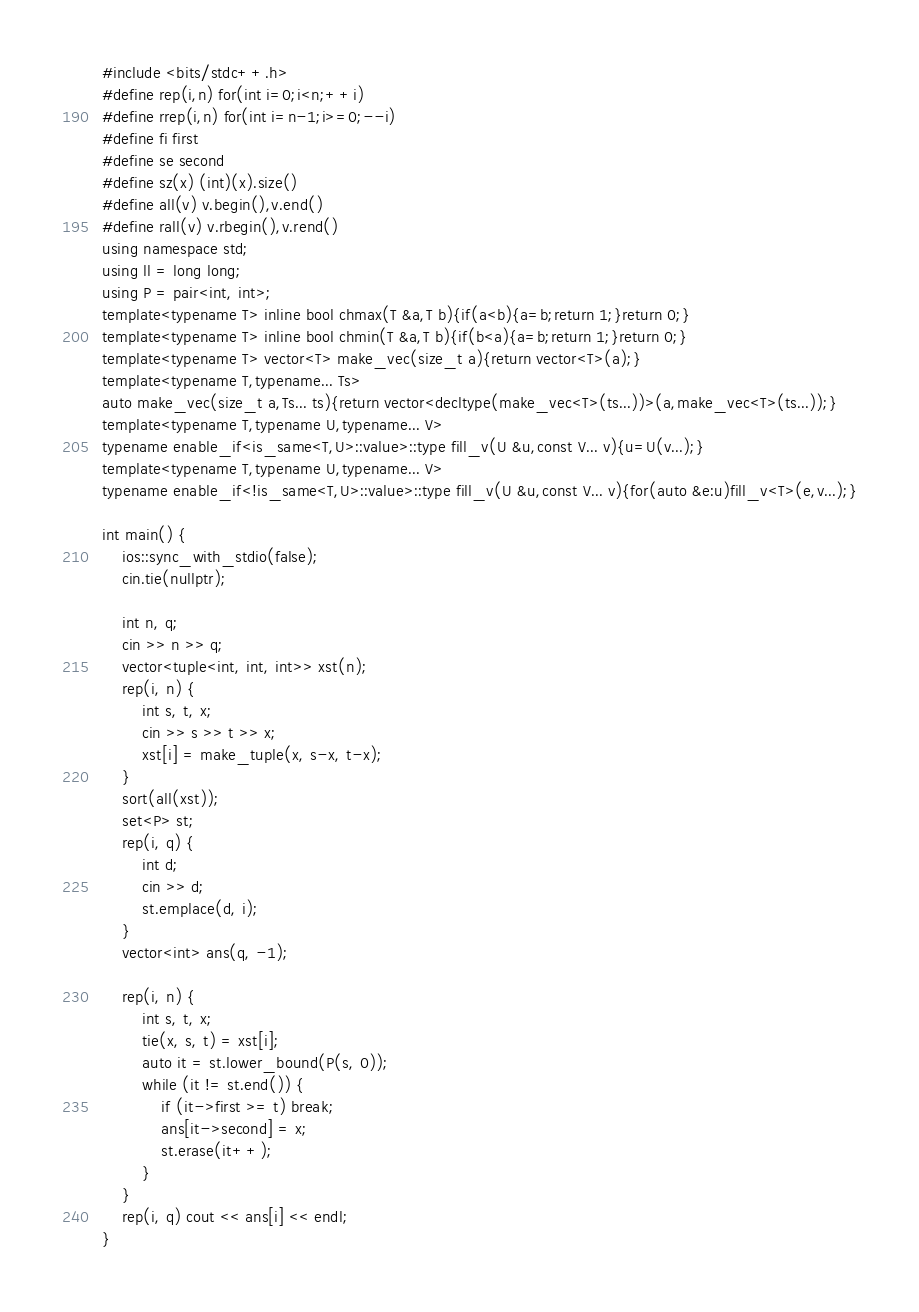Convert code to text. <code><loc_0><loc_0><loc_500><loc_500><_C++_>#include <bits/stdc++.h>
#define rep(i,n) for(int i=0;i<n;++i)
#define rrep(i,n) for(int i=n-1;i>=0;--i)
#define fi first
#define se second
#define sz(x) (int)(x).size()
#define all(v) v.begin(),v.end()
#define rall(v) v.rbegin(),v.rend()
using namespace std;
using ll = long long;
using P = pair<int, int>;
template<typename T> inline bool chmax(T &a,T b){if(a<b){a=b;return 1;}return 0;}
template<typename T> inline bool chmin(T &a,T b){if(b<a){a=b;return 1;}return 0;}
template<typename T> vector<T> make_vec(size_t a){return vector<T>(a);}
template<typename T,typename... Ts>
auto make_vec(size_t a,Ts... ts){return vector<decltype(make_vec<T>(ts...))>(a,make_vec<T>(ts...));}
template<typename T,typename U,typename... V>
typename enable_if<is_same<T,U>::value>::type fill_v(U &u,const V... v){u=U(v...);}
template<typename T,typename U,typename... V>
typename enable_if<!is_same<T,U>::value>::type fill_v(U &u,const V... v){for(auto &e:u)fill_v<T>(e,v...);}

int main() {
    ios::sync_with_stdio(false);
    cin.tie(nullptr);

    int n, q;
    cin >> n >> q;
    vector<tuple<int, int, int>> xst(n);
    rep(i, n) {
        int s, t, x;
        cin >> s >> t >> x;
        xst[i] = make_tuple(x, s-x, t-x);
    }
    sort(all(xst));
    set<P> st;
    rep(i, q) {
        int d;
        cin >> d;
        st.emplace(d, i);
    }
    vector<int> ans(q, -1);

    rep(i, n) {
        int s, t, x;
        tie(x, s, t) = xst[i];
        auto it = st.lower_bound(P(s, 0));
        while (it != st.end()) {
            if (it->first >= t) break;
            ans[it->second] = x;
            st.erase(it++);
        }
    }
    rep(i, q) cout << ans[i] << endl;
}
</code> 